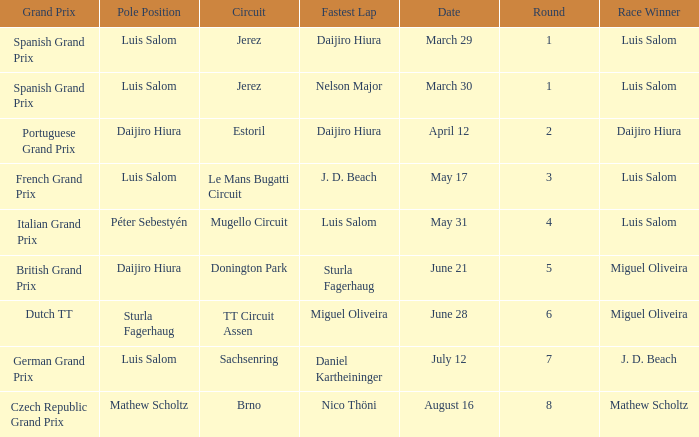Which round 5 Grand Prix had Daijiro Hiura at pole position?  British Grand Prix. 